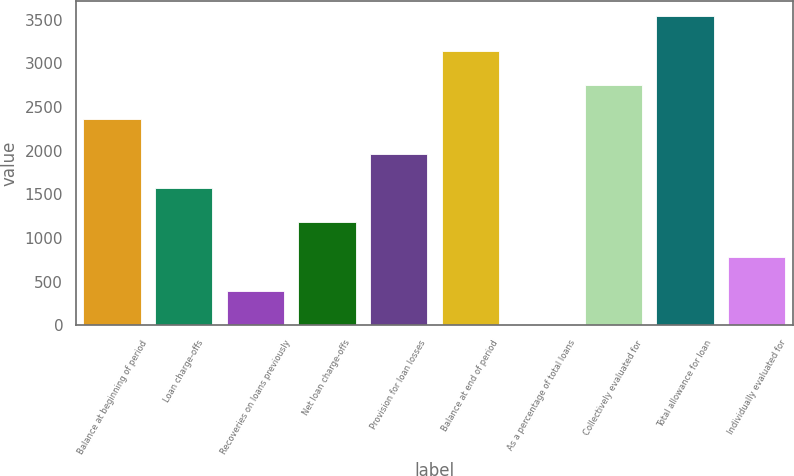<chart> <loc_0><loc_0><loc_500><loc_500><bar_chart><fcel>Balance at beginning of period<fcel>Loan charge-offs<fcel>Recoveries on loans previously<fcel>Net loan charge-offs<fcel>Provision for loan losses<fcel>Balance at end of period<fcel>As a percentage of total loans<fcel>Collectively evaluated for<fcel>Total allowance for loan<fcel>Individually evaluated for<nl><fcel>2358.76<fcel>1573.16<fcel>394.76<fcel>1180.36<fcel>1965.96<fcel>3144.36<fcel>1.96<fcel>2751.56<fcel>3537.16<fcel>787.56<nl></chart> 